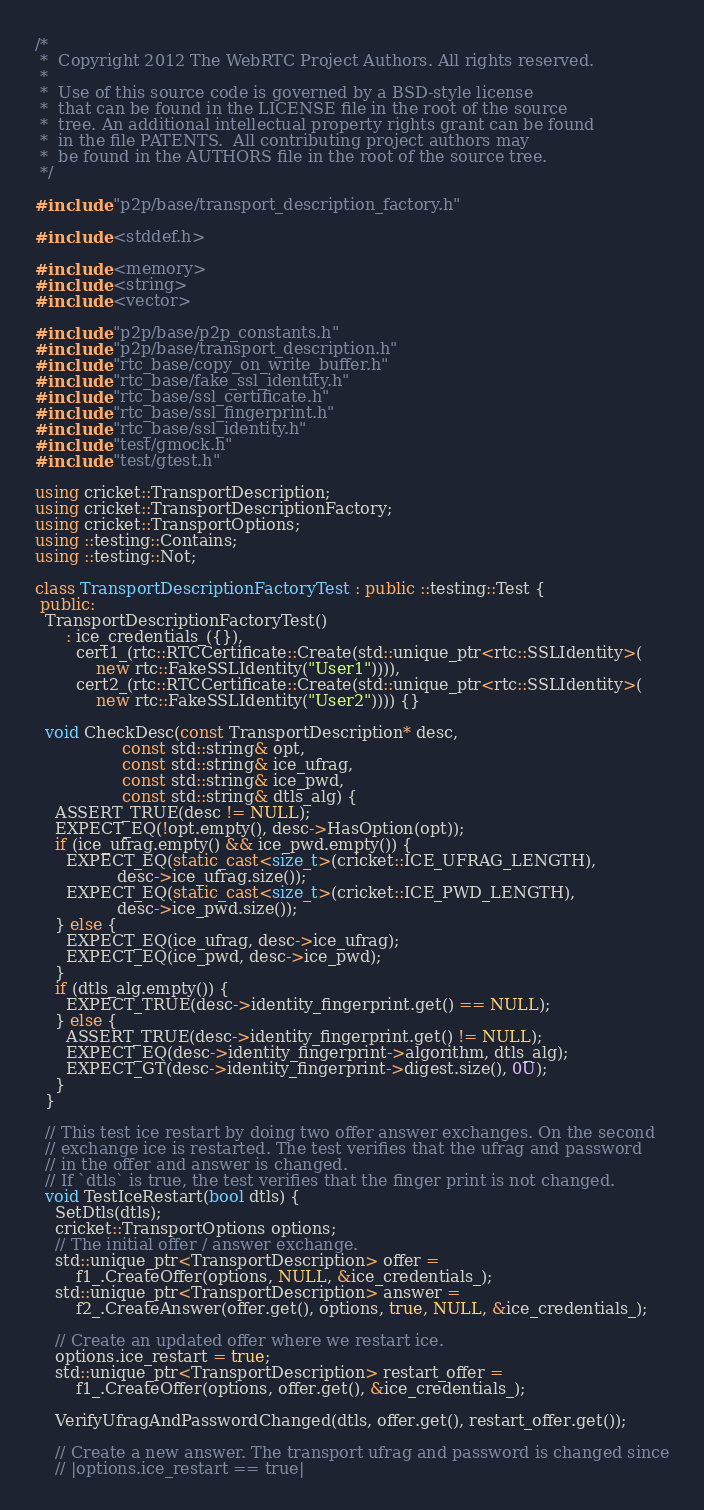<code> <loc_0><loc_0><loc_500><loc_500><_C++_>/*
 *  Copyright 2012 The WebRTC Project Authors. All rights reserved.
 *
 *  Use of this source code is governed by a BSD-style license
 *  that can be found in the LICENSE file in the root of the source
 *  tree. An additional intellectual property rights grant can be found
 *  in the file PATENTS.  All contributing project authors may
 *  be found in the AUTHORS file in the root of the source tree.
 */

#include "p2p/base/transport_description_factory.h"

#include <stddef.h>

#include <memory>
#include <string>
#include <vector>

#include "p2p/base/p2p_constants.h"
#include "p2p/base/transport_description.h"
#include "rtc_base/copy_on_write_buffer.h"
#include "rtc_base/fake_ssl_identity.h"
#include "rtc_base/ssl_certificate.h"
#include "rtc_base/ssl_fingerprint.h"
#include "rtc_base/ssl_identity.h"
#include "test/gmock.h"
#include "test/gtest.h"

using cricket::TransportDescription;
using cricket::TransportDescriptionFactory;
using cricket::TransportOptions;
using ::testing::Contains;
using ::testing::Not;

class TransportDescriptionFactoryTest : public ::testing::Test {
 public:
  TransportDescriptionFactoryTest()
      : ice_credentials_({}),
        cert1_(rtc::RTCCertificate::Create(std::unique_ptr<rtc::SSLIdentity>(
            new rtc::FakeSSLIdentity("User1")))),
        cert2_(rtc::RTCCertificate::Create(std::unique_ptr<rtc::SSLIdentity>(
            new rtc::FakeSSLIdentity("User2")))) {}

  void CheckDesc(const TransportDescription* desc,
                 const std::string& opt,
                 const std::string& ice_ufrag,
                 const std::string& ice_pwd,
                 const std::string& dtls_alg) {
    ASSERT_TRUE(desc != NULL);
    EXPECT_EQ(!opt.empty(), desc->HasOption(opt));
    if (ice_ufrag.empty() && ice_pwd.empty()) {
      EXPECT_EQ(static_cast<size_t>(cricket::ICE_UFRAG_LENGTH),
                desc->ice_ufrag.size());
      EXPECT_EQ(static_cast<size_t>(cricket::ICE_PWD_LENGTH),
                desc->ice_pwd.size());
    } else {
      EXPECT_EQ(ice_ufrag, desc->ice_ufrag);
      EXPECT_EQ(ice_pwd, desc->ice_pwd);
    }
    if (dtls_alg.empty()) {
      EXPECT_TRUE(desc->identity_fingerprint.get() == NULL);
    } else {
      ASSERT_TRUE(desc->identity_fingerprint.get() != NULL);
      EXPECT_EQ(desc->identity_fingerprint->algorithm, dtls_alg);
      EXPECT_GT(desc->identity_fingerprint->digest.size(), 0U);
    }
  }

  // This test ice restart by doing two offer answer exchanges. On the second
  // exchange ice is restarted. The test verifies that the ufrag and password
  // in the offer and answer is changed.
  // If `dtls` is true, the test verifies that the finger print is not changed.
  void TestIceRestart(bool dtls) {
    SetDtls(dtls);
    cricket::TransportOptions options;
    // The initial offer / answer exchange.
    std::unique_ptr<TransportDescription> offer =
        f1_.CreateOffer(options, NULL, &ice_credentials_);
    std::unique_ptr<TransportDescription> answer =
        f2_.CreateAnswer(offer.get(), options, true, NULL, &ice_credentials_);

    // Create an updated offer where we restart ice.
    options.ice_restart = true;
    std::unique_ptr<TransportDescription> restart_offer =
        f1_.CreateOffer(options, offer.get(), &ice_credentials_);

    VerifyUfragAndPasswordChanged(dtls, offer.get(), restart_offer.get());

    // Create a new answer. The transport ufrag and password is changed since
    // |options.ice_restart == true|</code> 